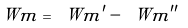<formula> <loc_0><loc_0><loc_500><loc_500>\ W m = \ W m ^ { \prime } - \ W m ^ { \prime \prime }</formula> 